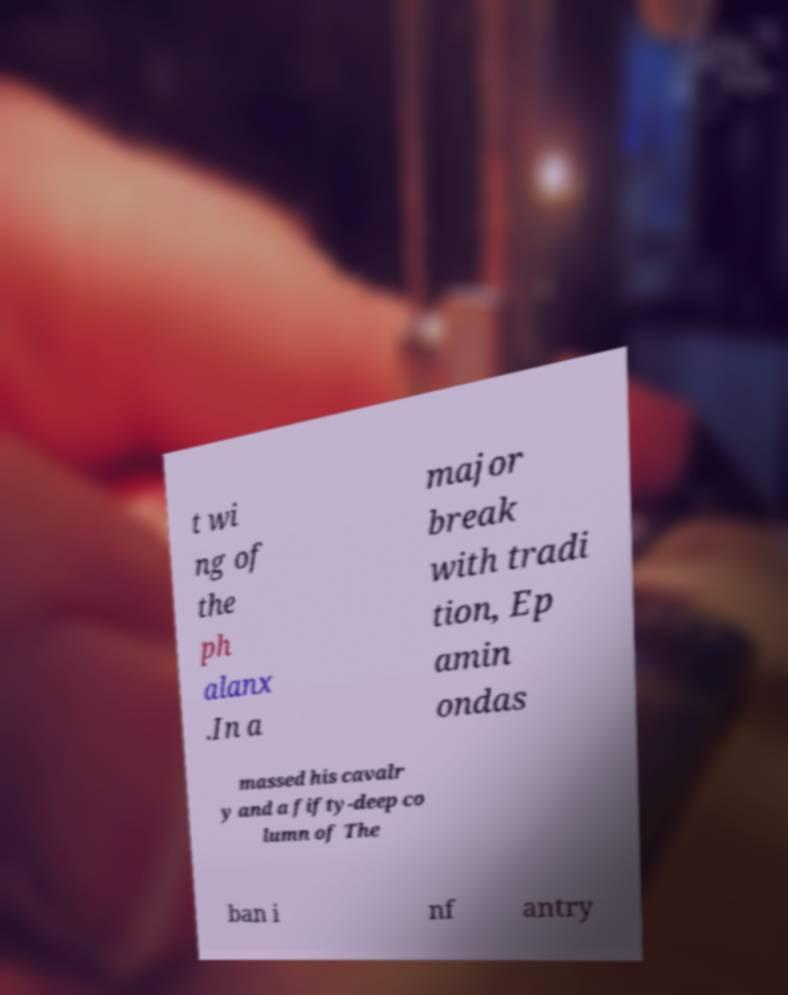There's text embedded in this image that I need extracted. Can you transcribe it verbatim? t wi ng of the ph alanx .In a major break with tradi tion, Ep amin ondas massed his cavalr y and a fifty-deep co lumn of The ban i nf antry 